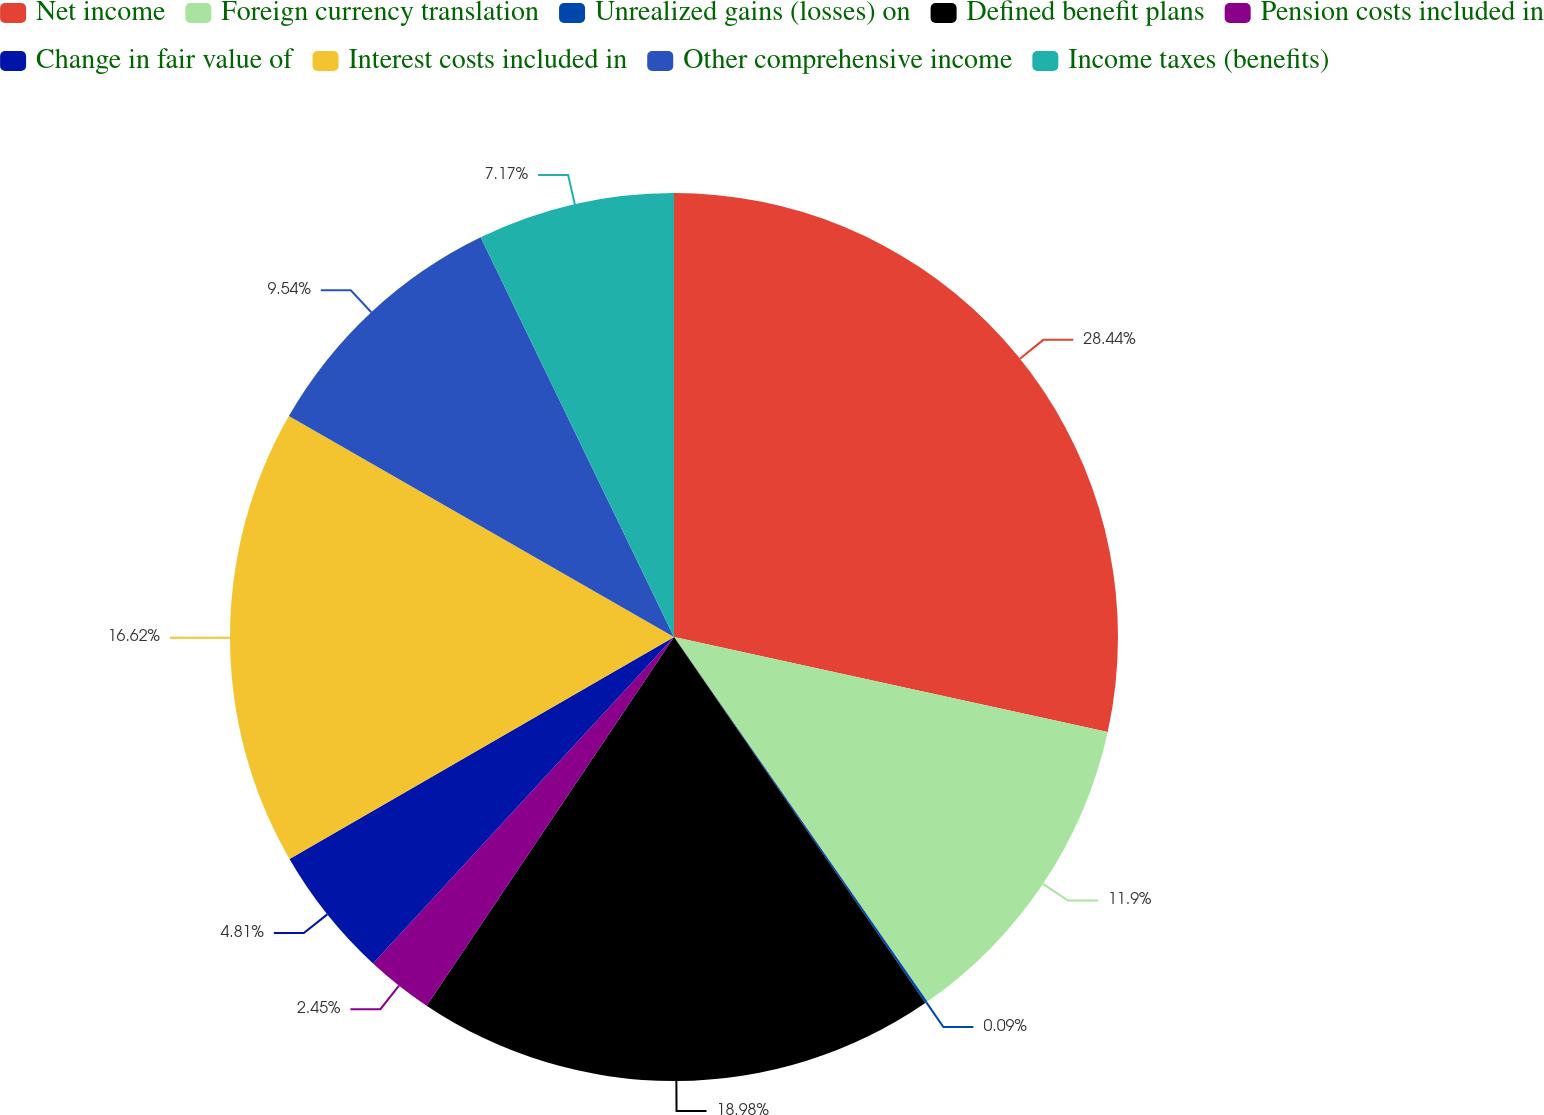<chart> <loc_0><loc_0><loc_500><loc_500><pie_chart><fcel>Net income<fcel>Foreign currency translation<fcel>Unrealized gains (losses) on<fcel>Defined benefit plans<fcel>Pension costs included in<fcel>Change in fair value of<fcel>Interest costs included in<fcel>Other comprehensive income<fcel>Income taxes (benefits)<nl><fcel>28.43%<fcel>11.9%<fcel>0.09%<fcel>18.98%<fcel>2.45%<fcel>4.81%<fcel>16.62%<fcel>9.54%<fcel>7.17%<nl></chart> 